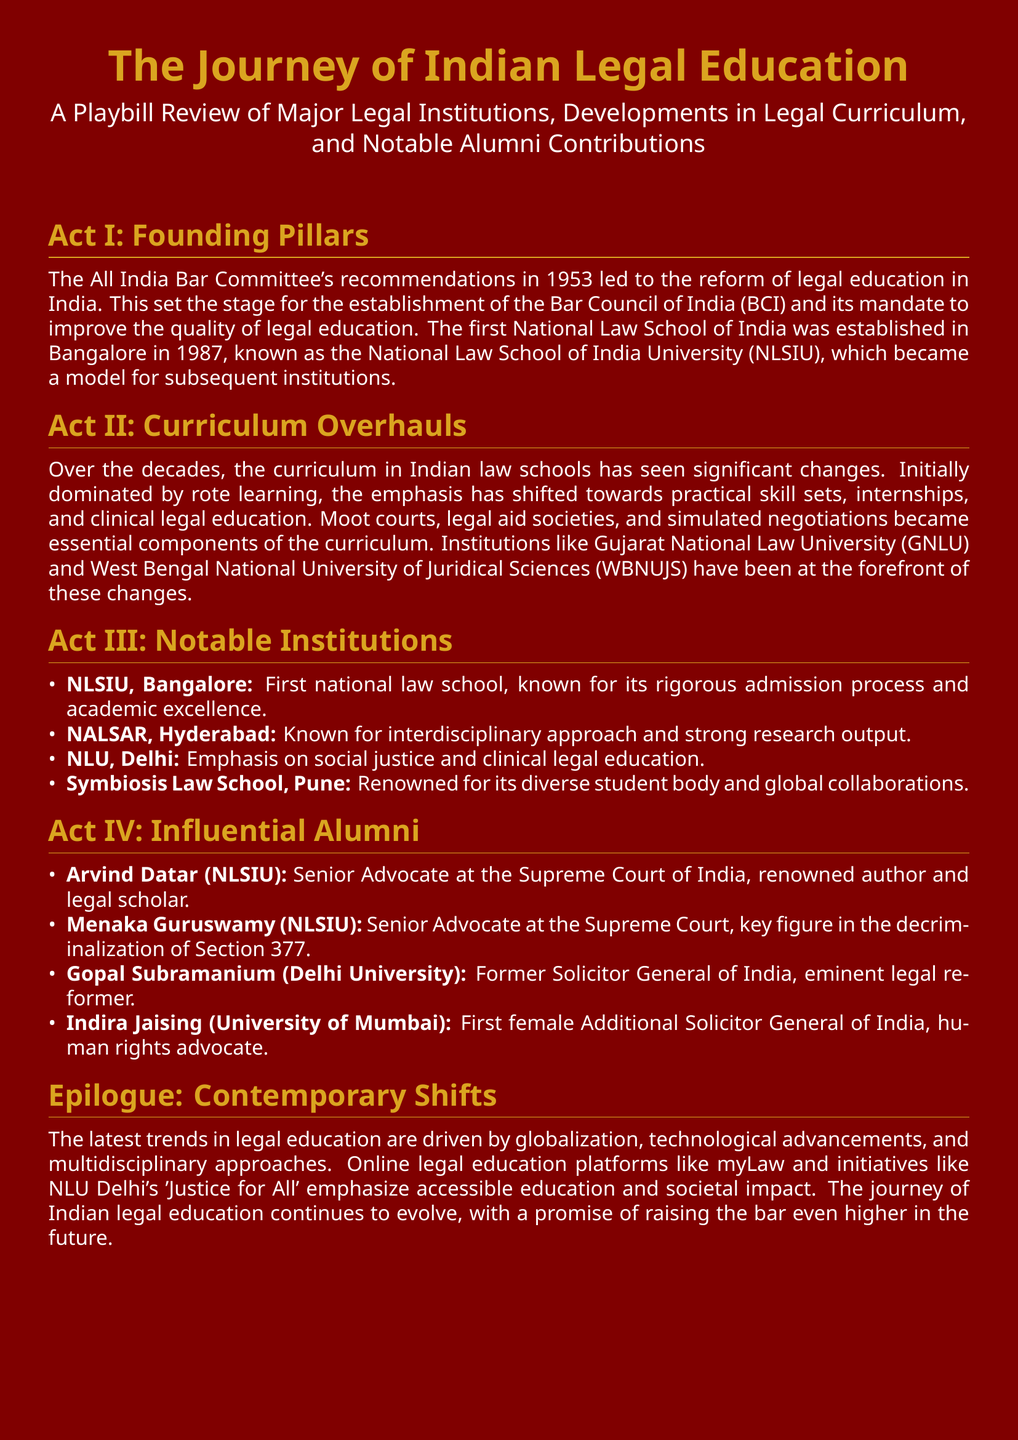What committee's recommendations in 1953 led to the reform of legal education? The All India Bar Committee's recommendations were pivotal in reforming legal education in India in 1953.
Answer: All India Bar Committee When was the first National Law School of India established? The document states that the first National Law School was established in Bangalore in 1987.
Answer: 1987 Which law school is known for its interdisciplinary approach? The document mentions that NALSAR, Hyderabad is recognized for its interdisciplinary approach.
Answer: NALSAR, Hyderabad Who is a notable alumnus from NLSIU known for their work on Section 377? Menaka Guruswamy is identified as a notable alumnus who played a key role in the decriminalization of Section 377.
Answer: Menaka Guruswamy What has the curriculum in Indian law schools shifted towards over the decades? The curriculum has shifted towards practical skill sets, internships, and clinical legal education.
Answer: Practical skill sets What latest trend in legal education emphasizes accessible education? Online legal education platforms like myLaw emphasize accessible education.
Answer: myLaw Which institution is recognized for its global collaborations? Symbiosis Law School in Pune is noted for its global collaborations.
Answer: Symbiosis Law School, Pune Who was the first female Additional Solicitor General of India? Indira Jaising is documented as the first female Additional Solicitor General of India.
Answer: Indira Jaising 